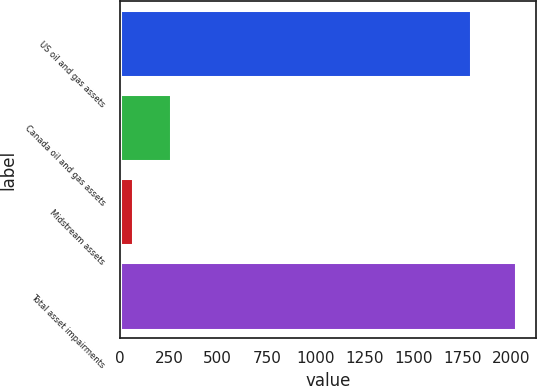Convert chart to OTSL. <chart><loc_0><loc_0><loc_500><loc_500><bar_chart><fcel>US oil and gas assets<fcel>Canada oil and gas assets<fcel>Midstream assets<fcel>Total asset impairments<nl><fcel>1793<fcel>263.6<fcel>68<fcel>2024<nl></chart> 